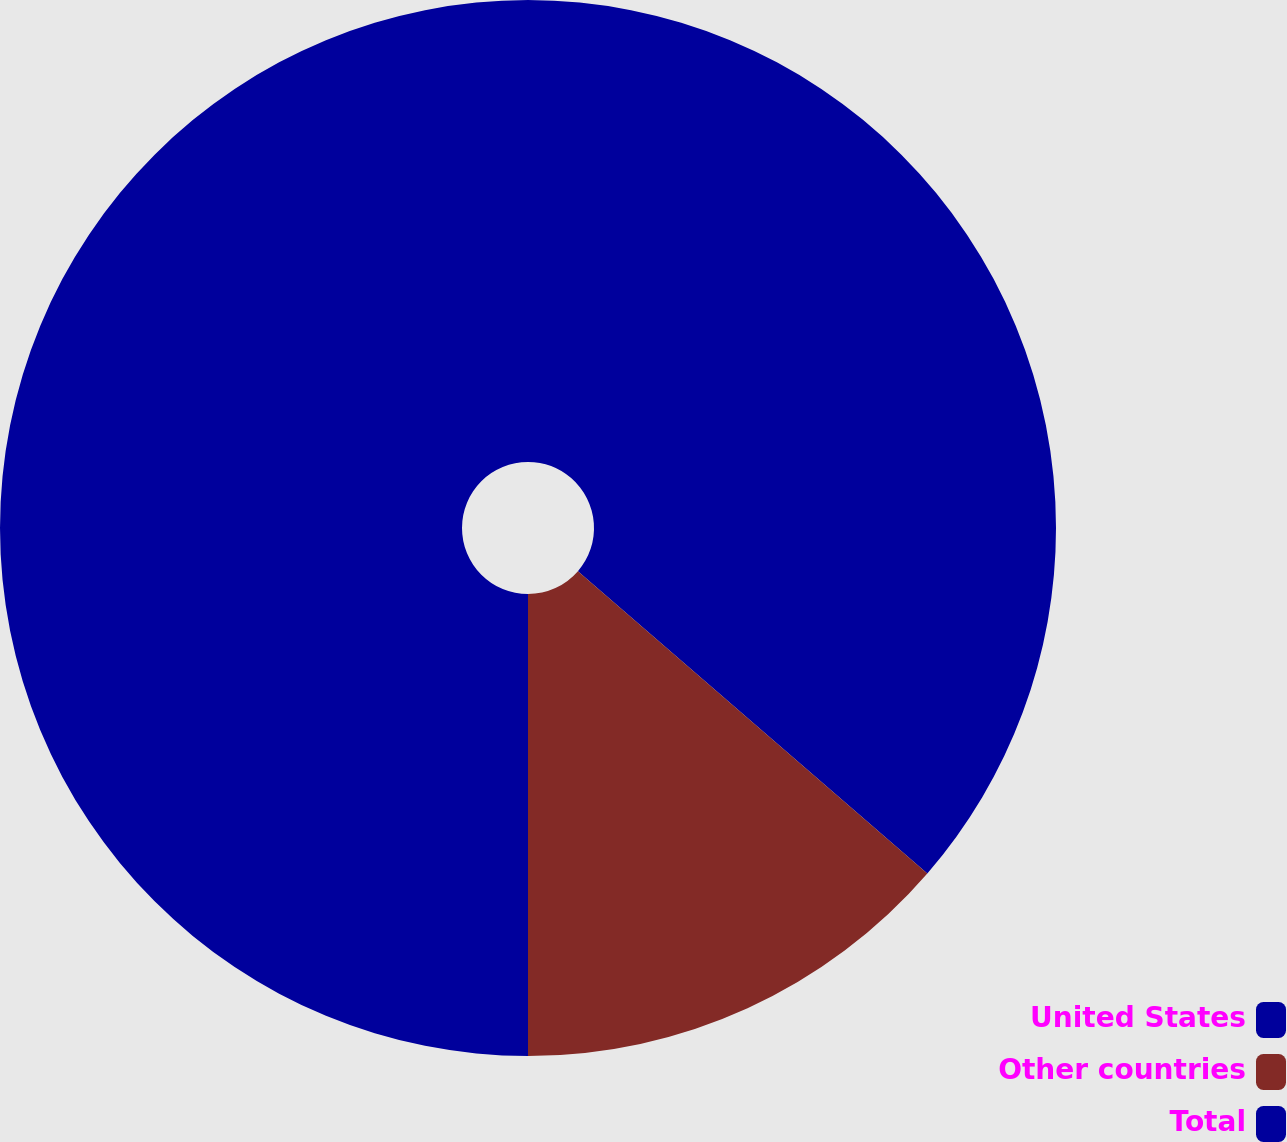<chart> <loc_0><loc_0><loc_500><loc_500><pie_chart><fcel>United States<fcel>Other countries<fcel>Total<nl><fcel>36.35%<fcel>13.65%<fcel>50.0%<nl></chart> 